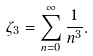Convert formula to latex. <formula><loc_0><loc_0><loc_500><loc_500>\zeta _ { 3 } = \sum _ { n = 0 } ^ { \infty } \frac { 1 } { n ^ { 3 } } .</formula> 